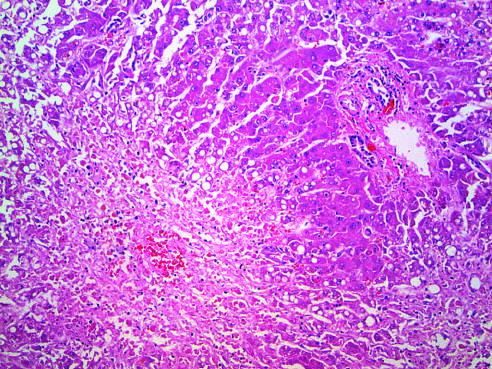what is caused by acetaminophen overdose?
Answer the question using a single word or phrase. Hepatocellular necrosis 